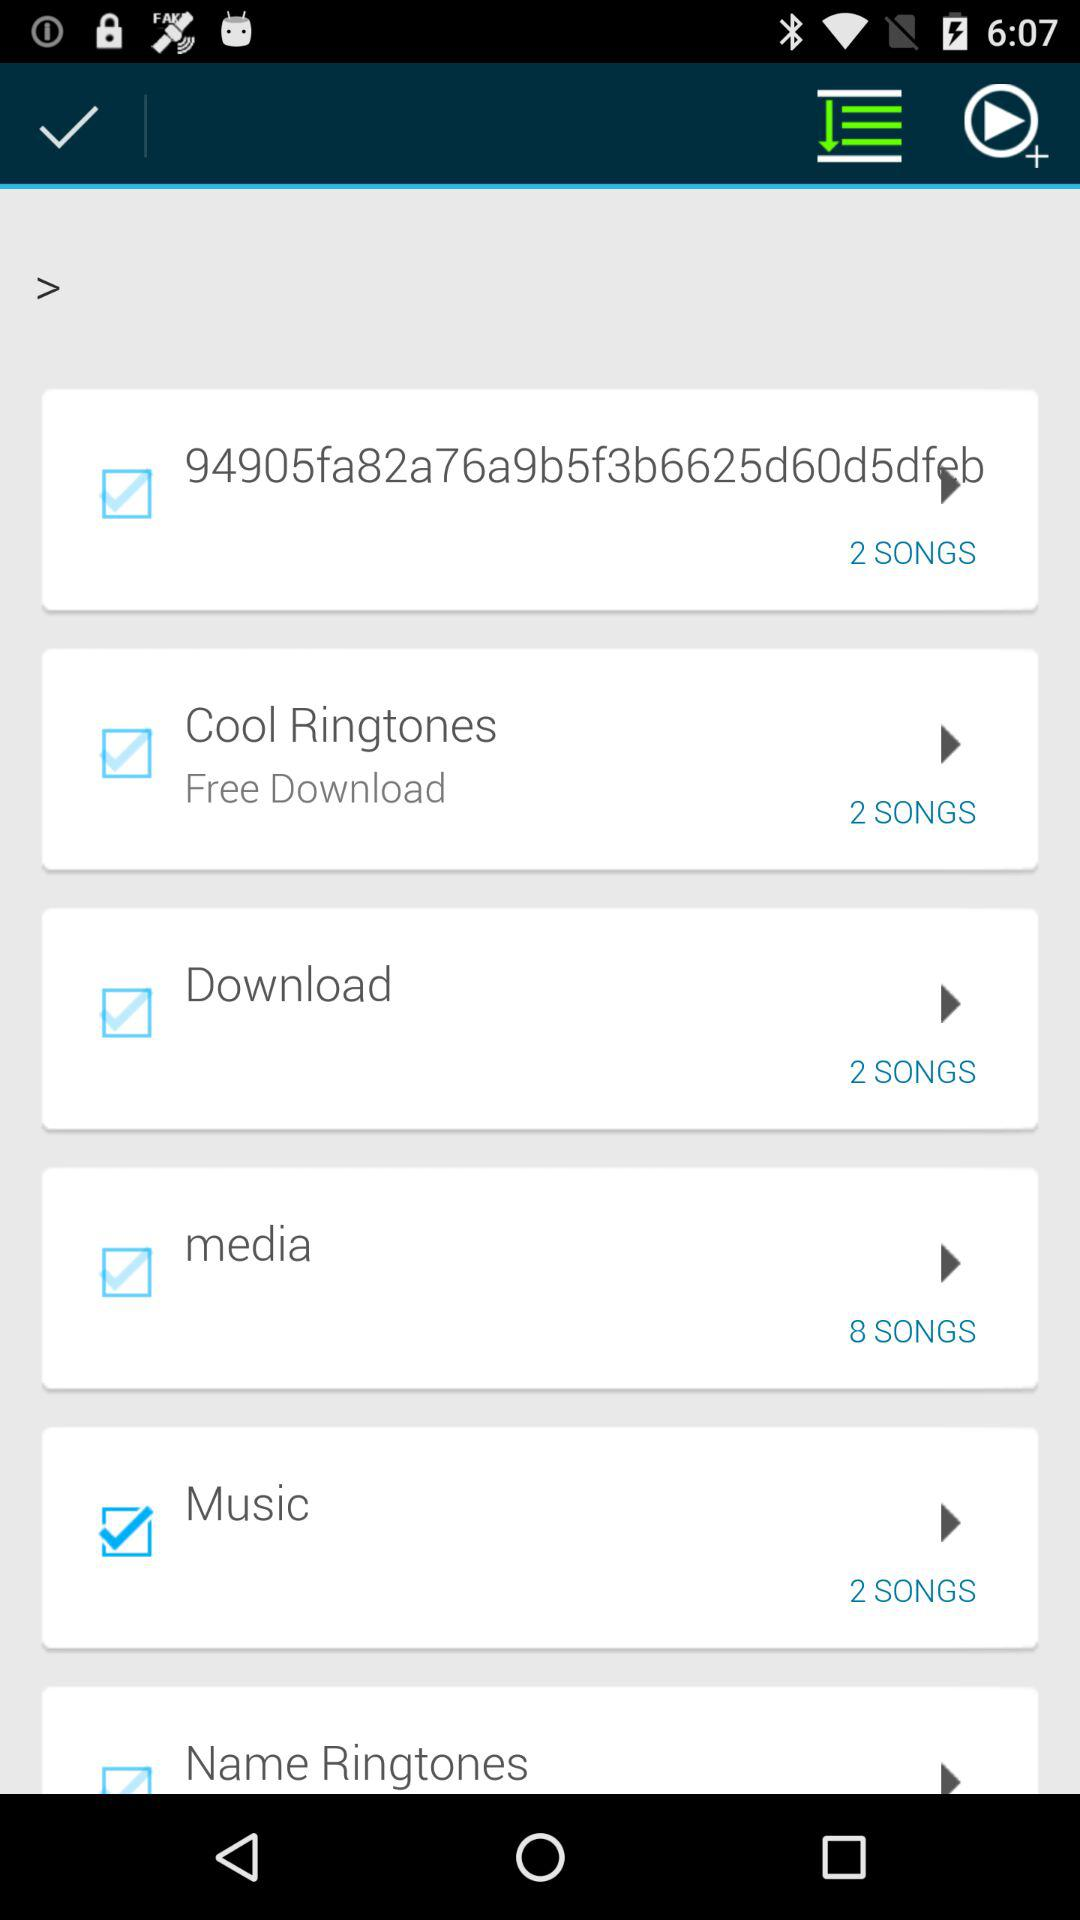What checkbox has been selected? The selected checkbox is "Music". 